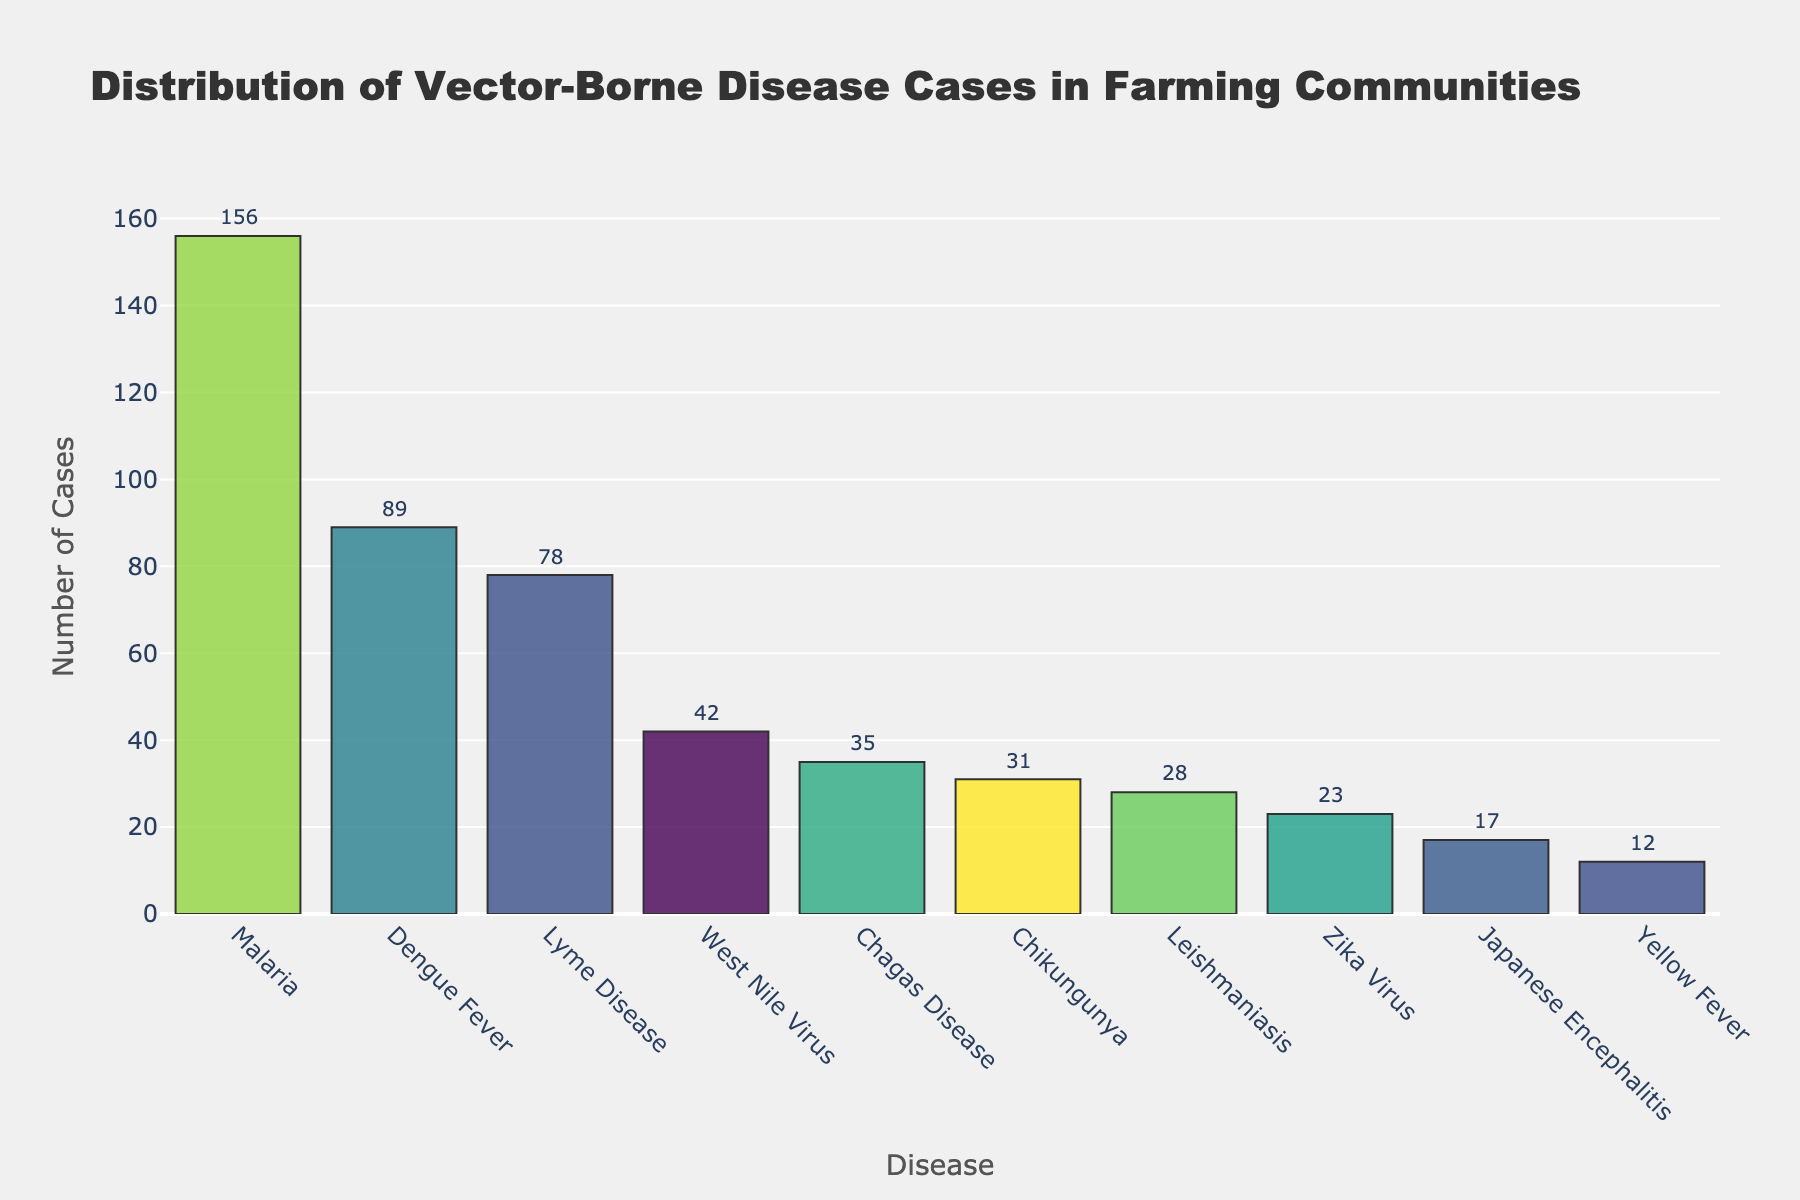What is the title of the histogram? The title is usually found at the top of the plot. It helps in understanding the context of the data being visualized. The title of this histogram is "Distribution of Vector-Borne Disease Cases in Farming Communities".
Answer: Distribution of Vector-Borne Disease Cases in Farming Communities Which disease has the highest number of cases? By looking at the highest bar in the histogram, we can identify which disease has the most cases. In this figure, the tallest bar corresponds to Malaria.
Answer: Malaria How many diseases have more than 40 cases? We count all bars whose height is above the 40 cases mark on the y-axis. By visual inspection, Malaria, Dengue Fever, West Nile Virus, and Lyme Disease have more than 40 cases.
Answer: 4 What is the total number of cases reported in the histogram? To find the total, sum the y-values of all bars: 156 + 89 + 42 + 78 + 31 + 17 + 23 + 35 + 28 + 12. Adding these together gives a total of 511 cases.
Answer: 511 Which disease has the fewest number of cases reported? By identifying the shortest bar in the histogram, we find that the disease with the fewest cases is Yellow Fever.
Answer: Yellow Fever How many more cases of Malaria are there compared to Dengue Fever? Subtract the number of cases of Dengue Fever from the number of cases of Malaria: 156 - 89 = 67.
Answer: 67 What is the average number of cases across all diseases? Calculate the average by summing all the cases and dividing by the number of diseases: (156 + 89 + 42 + 78 + 31 + 17 + 23 + 35 + 28 + 12) / 10 = 51.1.
Answer: 51.1 What is the range of the number of cases reported in the histogram? The range is found by subtracting the smallest number of cases from the largest number: 156 (Malaria) - 12 (Yellow Fever) = 144.
Answer: 144 Which diseases have fewer than 30 cases? Identify the bars that are below the 30 cases mark on the y-axis. Chikungunya, Japanese Encephalitis, Zika Virus, Leishmaniasis, and Yellow Fever all have fewer than 30 cases.
Answer: Chikungunya, Japanese Encephalitis, Zika Virus, Leishmaniasis, Yellow Fever What is the median number of cases for the diseases reported? To find the median, list the number of cases in ascending order and find the middle value: 12, 17, 23, 28, 31, 35, 42, 78, 89, 156. The median is the average of the 5th and 6th values: (31 + 35) / 2 = 33.
Answer: 33 